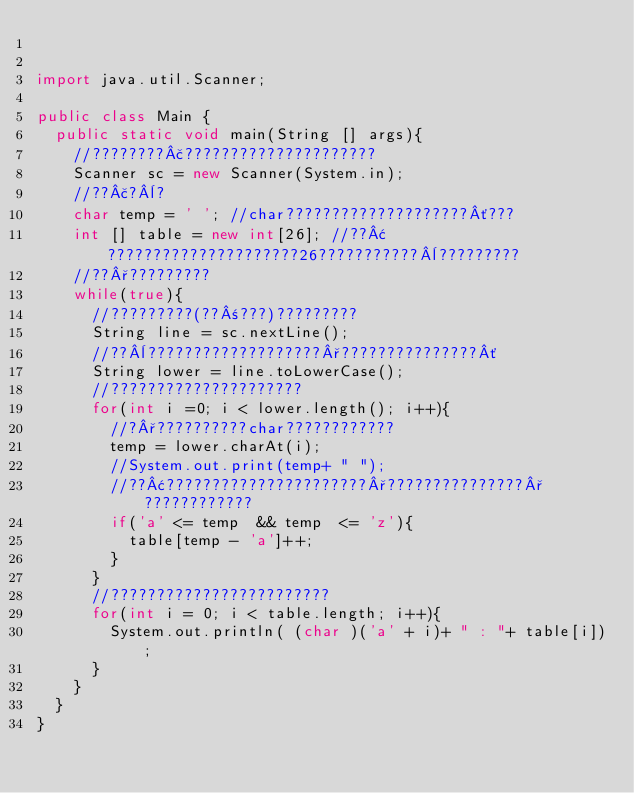<code> <loc_0><loc_0><loc_500><loc_500><_Java_>

import java.util.Scanner;

public class Main {
	public static void main(String [] args){
		//????????£?????????????????????
		Scanner sc = new Scanner(System.in);
		//??£?¨?
		char temp = ' '; //char????????????????????´???
		int [] table = new int[26]; //??¢?????????????????????26???????????¨?????????
		//??°?????????
		while(true){
			//?????????(??±???)?????????
			String line = sc.nextLine();
			//??¨???????????????????°???????????????´
			String lower = line.toLowerCase();
			//?????????????????????
			for(int i =0; i < lower.length(); i++){
				//?°??????????char????????????
				temp = lower.charAt(i);
				//System.out.print(temp+ " ");
				//??¢??????????????????????°???????????????°????????????
				if('a' <= temp  && temp  <= 'z'){
					table[temp - 'a']++;
				}
			}
			//????????????????????????
			for(int i = 0; i < table.length; i++){
				System.out.println( (char )('a' + i)+ " : "+ table[i]);
			}
		}
	}
}</code> 